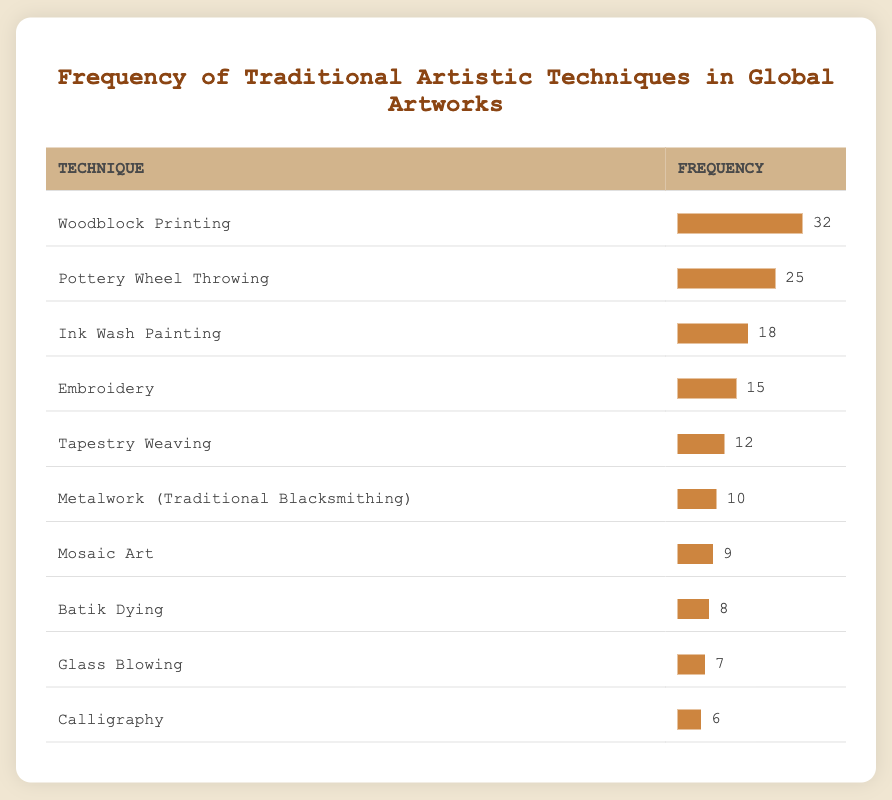What is the most frequently utilized artistic technique? The table shows the frequency of various artistic techniques; looking at the frequencies, Woodblock Printing has the highest frequency at 32.
Answer: Woodblock Printing How many times is the technique "Embroidery" utilized? The table lists the frequency for Embroidery as 15.
Answer: 15 Which technique has a frequency that is greater than 10 but less than 20? By filtering the techniques with frequencies listed in the table, the only technique that fits this criterion is Ink Wash Painting (18) and Embroidery (15).
Answer: Ink Wash Painting, Embroidery What is the total frequency of all the artistic techniques listed? To find the total frequency, we sum the frequencies of all techniques: 32 + 25 + 18 + 15 + 12 + 10 + 9 + 8 + 7 + 6 = 142.
Answer: 142 Is the frequency of "Glass Blowing" greater than the frequency of "Calligraphy"? The frequency for Glass Blowing is 7, and for Calligraphy, it is 6. Since 7 is greater than 6, the statement is true.
Answer: Yes Which technique has the lowest frequency of utilization? The frequencies listed in the table indicate that Calligraphy, with a frequency of 6, is the lowest utilized technique.
Answer: Calligraphy What is the average frequency of the artistic techniques listed? To find the average, we take the total frequency (142) and divide it by the number of techniques (10): 142 / 10 = 14.2.
Answer: 14.2 Which artistic technique's frequency differs the most from the average frequency? The average frequency is 14.2. The differences from the average for each technique are calculated, showing that Woodblock Printing (32) has the largest difference from the average (17.8), and Calligraphy (6) has the smallest difference (8.2).
Answer: Woodblock Printing and Calligraphy Is "Mosaic Art" utilized more times than "Batik Dying"? From the table, Mosaic Art has a frequency of 9 and Batik Dying has a frequency of 8. Since 9 is greater than 8, the statement is true.
Answer: Yes 